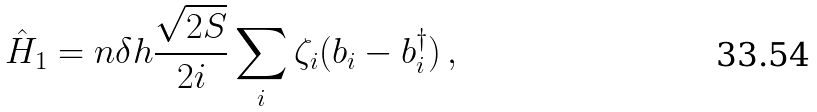<formula> <loc_0><loc_0><loc_500><loc_500>\hat { H } _ { 1 } = n \delta h \frac { \sqrt { 2 S } } { 2 i } \sum _ { i } \zeta _ { i } ( b _ { i } - b ^ { \dagger } _ { i } ) \, ,</formula> 